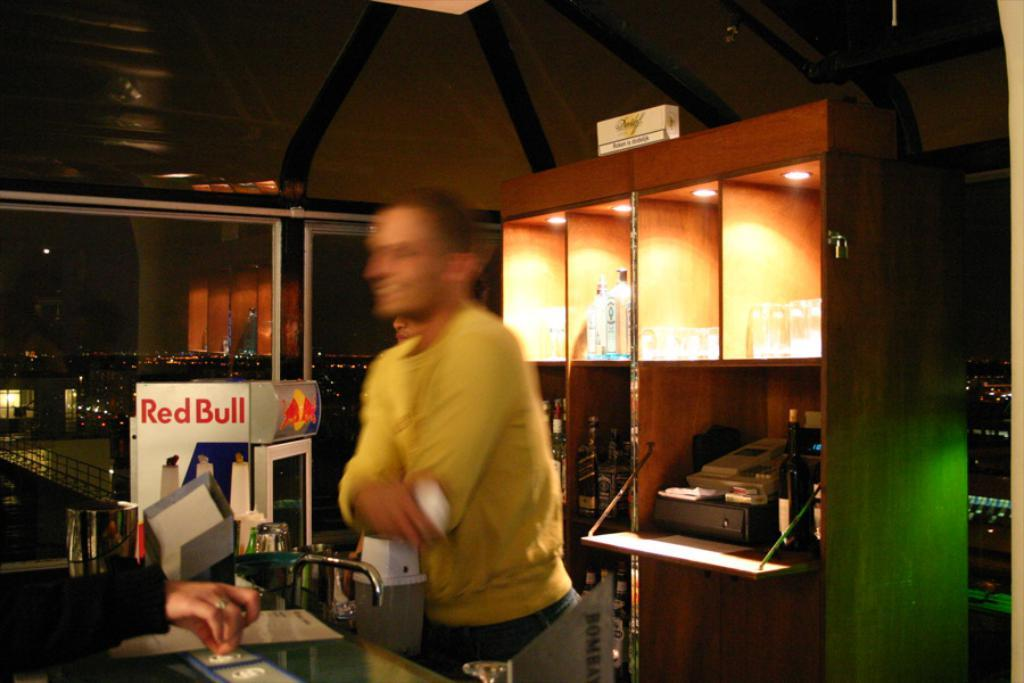Provide a one-sentence caption for the provided image. A person in a yellow shirt stands beside a container that says Red Bull. 